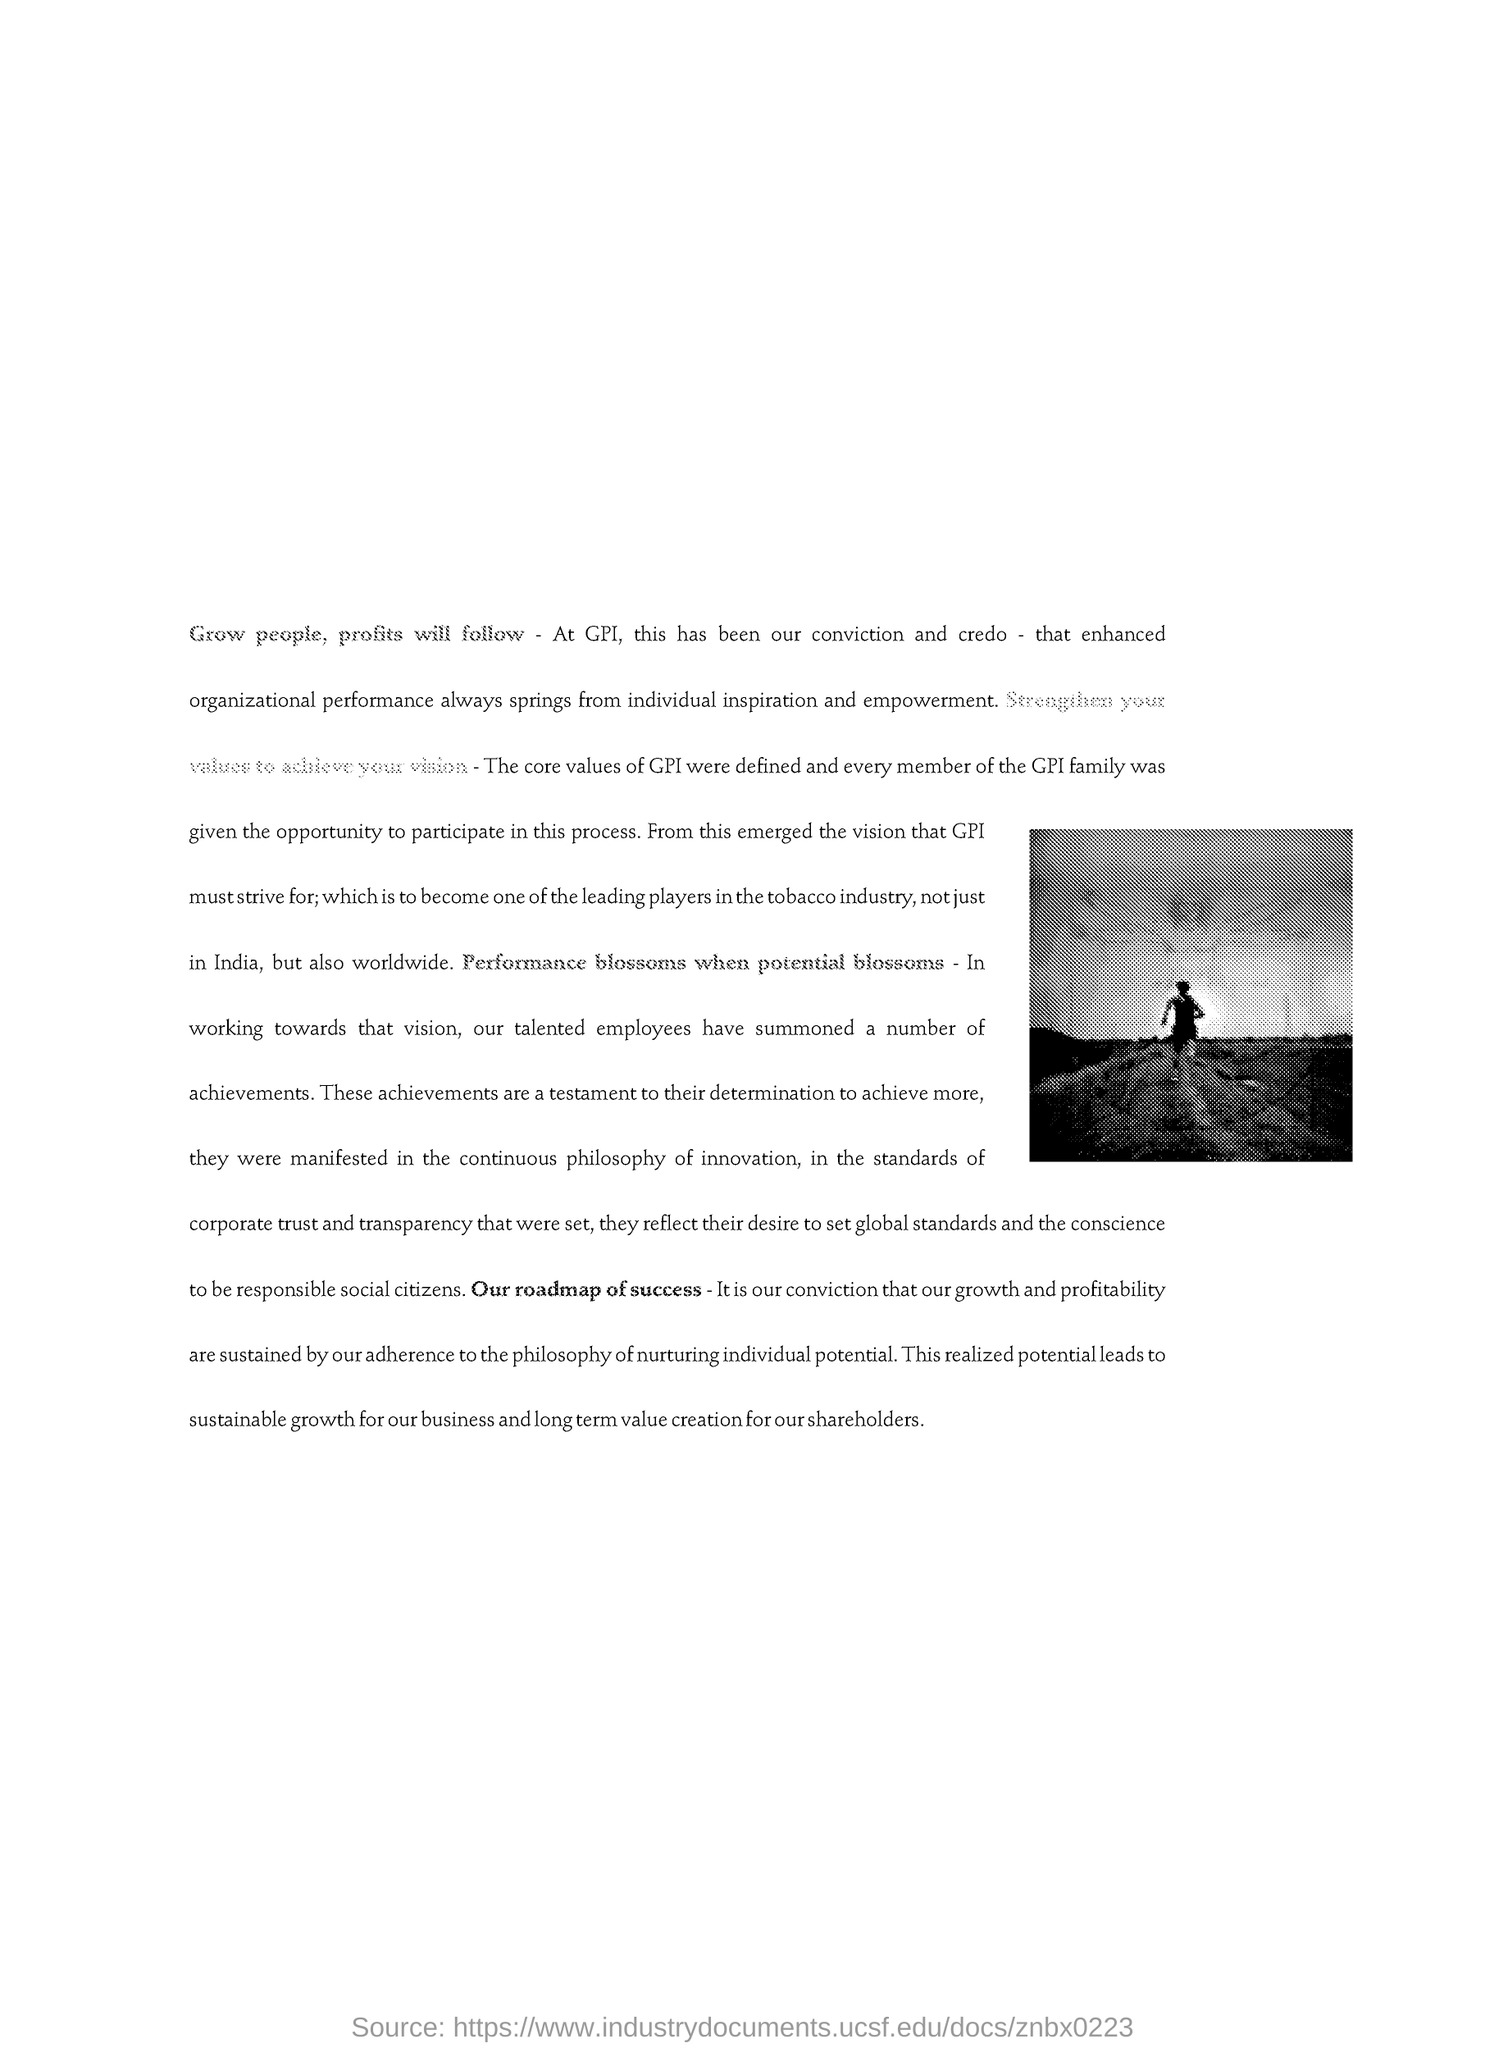What is written in bold?
Give a very brief answer. Our roadmap of success. 